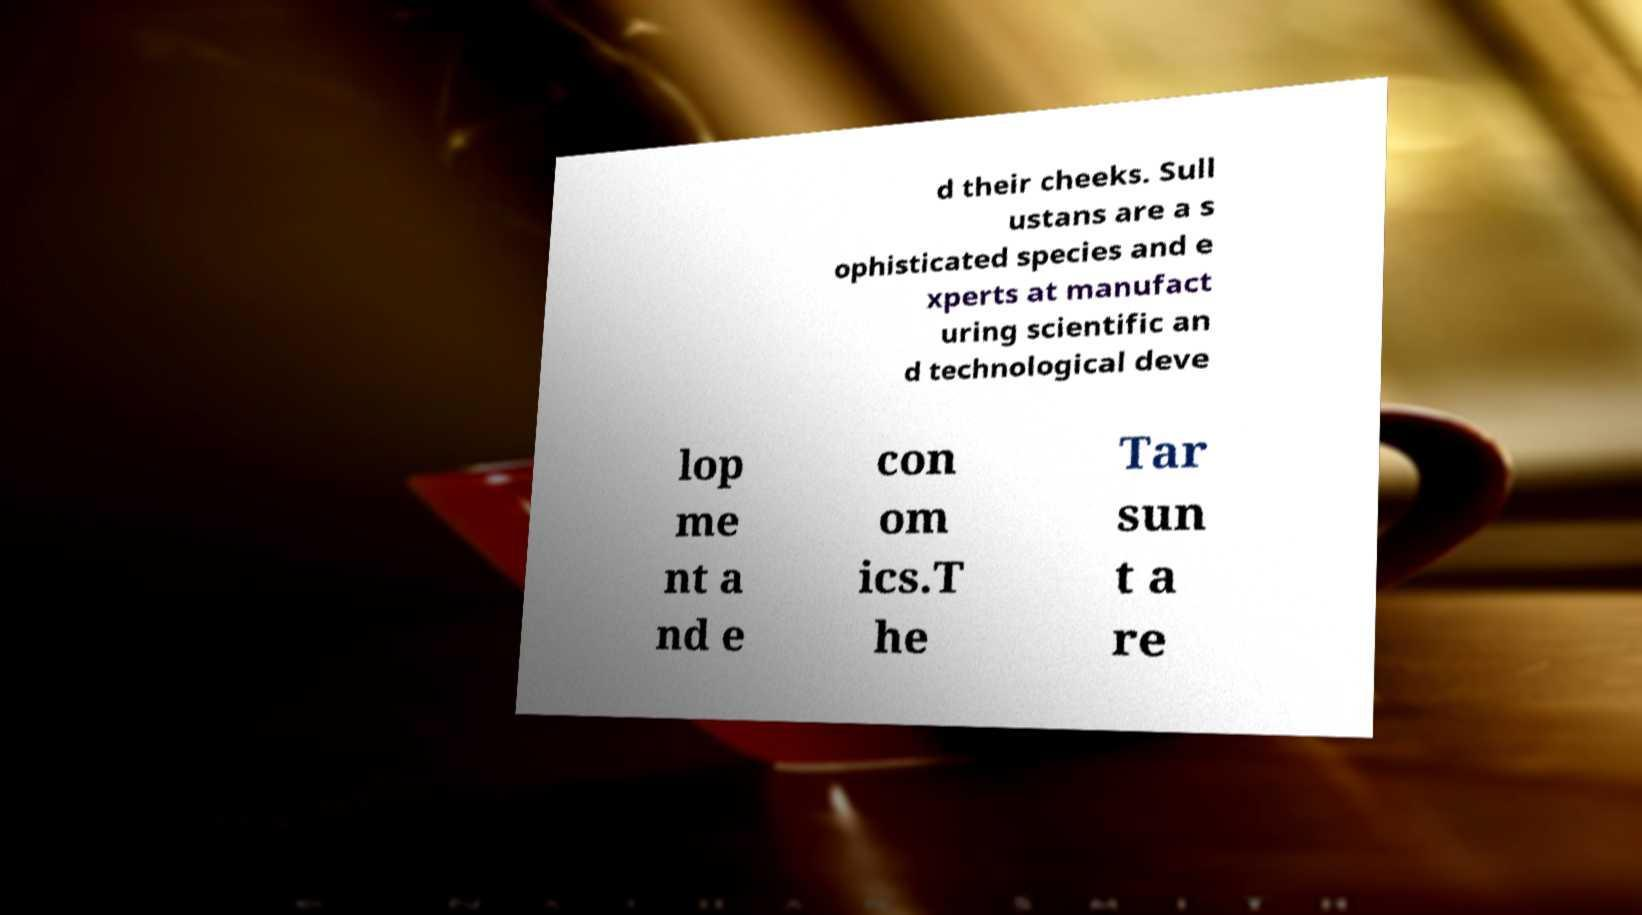Could you assist in decoding the text presented in this image and type it out clearly? d their cheeks. Sull ustans are a s ophisticated species and e xperts at manufact uring scientific an d technological deve lop me nt a nd e con om ics.T he Tar sun t a re 